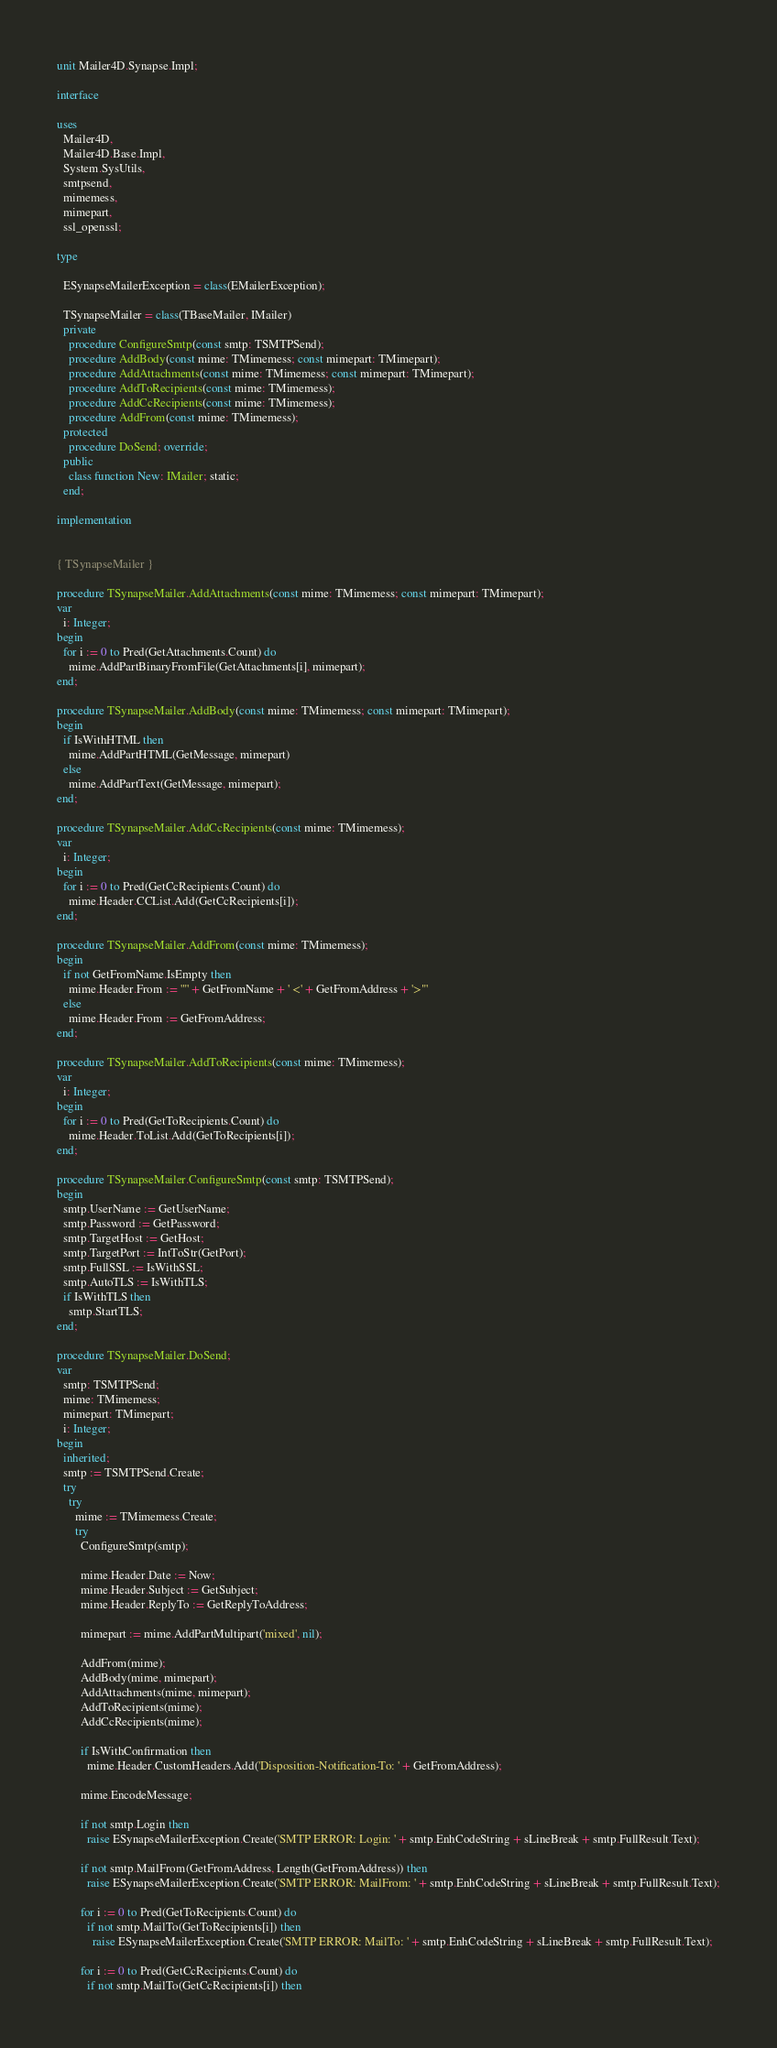<code> <loc_0><loc_0><loc_500><loc_500><_Pascal_>unit Mailer4D.Synapse.Impl;

interface

uses
  Mailer4D,
  Mailer4D.Base.Impl,
  System.SysUtils,
  smtpsend,
  mimemess,
  mimepart,
  ssl_openssl;

type

  ESynapseMailerException = class(EMailerException);

  TSynapseMailer = class(TBaseMailer, IMailer)
  private
    procedure ConfigureSmtp(const smtp: TSMTPSend);
    procedure AddBody(const mime: TMimemess; const mimepart: TMimepart);
    procedure AddAttachments(const mime: TMimemess; const mimepart: TMimepart);
    procedure AddToRecipients(const mime: TMimemess);
    procedure AddCcRecipients(const mime: TMimemess);
    procedure AddFrom(const mime: TMimemess);
  protected
    procedure DoSend; override;
  public
    class function New: IMailer; static;
  end;

implementation


{ TSynapseMailer }

procedure TSynapseMailer.AddAttachments(const mime: TMimemess; const mimepart: TMimepart);
var
  i: Integer;
begin
  for i := 0 to Pred(GetAttachments.Count) do
    mime.AddPartBinaryFromFile(GetAttachments[i], mimepart);
end;

procedure TSynapseMailer.AddBody(const mime: TMimemess; const mimepart: TMimepart);
begin
  if IsWithHTML then
    mime.AddPartHTML(GetMessage, mimepart)
  else
    mime.AddPartText(GetMessage, mimepart);
end;

procedure TSynapseMailer.AddCcRecipients(const mime: TMimemess);
var
  i: Integer;
begin
  for i := 0 to Pred(GetCcRecipients.Count) do
    mime.Header.CCList.Add(GetCcRecipients[i]);
end;

procedure TSynapseMailer.AddFrom(const mime: TMimemess);
begin
  if not GetFromName.IsEmpty then
    mime.Header.From := '"' + GetFromName + ' <' + GetFromAddress + '>"'
  else
    mime.Header.From := GetFromAddress;
end;

procedure TSynapseMailer.AddToRecipients(const mime: TMimemess);
var
  i: Integer;
begin
  for i := 0 to Pred(GetToRecipients.Count) do
    mime.Header.ToList.Add(GetToRecipients[i]);
end;

procedure TSynapseMailer.ConfigureSmtp(const smtp: TSMTPSend);
begin
  smtp.UserName := GetUserName;
  smtp.Password := GetPassword;
  smtp.TargetHost := GetHost;
  smtp.TargetPort := IntToStr(GetPort);
  smtp.FullSSL := IsWithSSL;
  smtp.AutoTLS := IsWithTLS;
  if IsWithTLS then
    smtp.StartTLS;
end;

procedure TSynapseMailer.DoSend;
var
  smtp: TSMTPSend;
  mime: TMimemess;
  mimepart: TMimepart;
  i: Integer;
begin
  inherited;
  smtp := TSMTPSend.Create;
  try
    try
      mime := TMimemess.Create;
      try
        ConfigureSmtp(smtp);

        mime.Header.Date := Now;
        mime.Header.Subject := GetSubject;
        mime.Header.ReplyTo := GetReplyToAddress;

        mimepart := mime.AddPartMultipart('mixed', nil);

        AddFrom(mime);
        AddBody(mime, mimepart);
        AddAttachments(mime, mimepart);
        AddToRecipients(mime);
        AddCcRecipients(mime);

        if IsWithConfirmation then
          mime.Header.CustomHeaders.Add('Disposition-Notification-To: ' + GetFromAddress);

        mime.EncodeMessage;

        if not smtp.Login then
          raise ESynapseMailerException.Create('SMTP ERROR: Login: ' + smtp.EnhCodeString + sLineBreak + smtp.FullResult.Text);

        if not smtp.MailFrom(GetFromAddress, Length(GetFromAddress)) then
          raise ESynapseMailerException.Create('SMTP ERROR: MailFrom: ' + smtp.EnhCodeString + sLineBreak + smtp.FullResult.Text);

        for i := 0 to Pred(GetToRecipients.Count) do
          if not smtp.MailTo(GetToRecipients[i]) then
            raise ESynapseMailerException.Create('SMTP ERROR: MailTo: ' + smtp.EnhCodeString + sLineBreak + smtp.FullResult.Text);

        for i := 0 to Pred(GetCcRecipients.Count) do
          if not smtp.MailTo(GetCcRecipients[i]) then</code> 